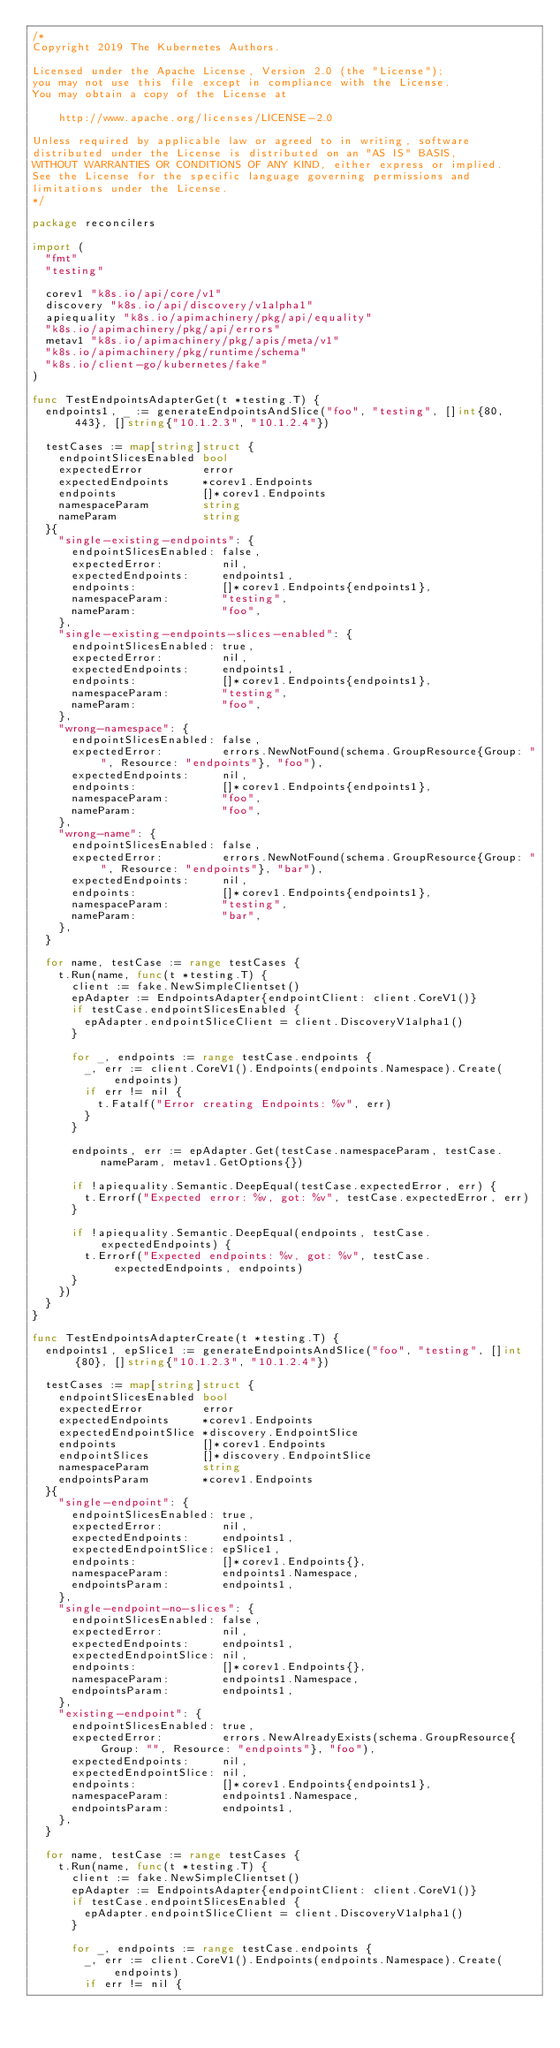<code> <loc_0><loc_0><loc_500><loc_500><_Go_>/*
Copyright 2019 The Kubernetes Authors.

Licensed under the Apache License, Version 2.0 (the "License");
you may not use this file except in compliance with the License.
You may obtain a copy of the License at

    http://www.apache.org/licenses/LICENSE-2.0

Unless required by applicable law or agreed to in writing, software
distributed under the License is distributed on an "AS IS" BASIS,
WITHOUT WARRANTIES OR CONDITIONS OF ANY KIND, either express or implied.
See the License for the specific language governing permissions and
limitations under the License.
*/

package reconcilers

import (
	"fmt"
	"testing"

	corev1 "k8s.io/api/core/v1"
	discovery "k8s.io/api/discovery/v1alpha1"
	apiequality "k8s.io/apimachinery/pkg/api/equality"
	"k8s.io/apimachinery/pkg/api/errors"
	metav1 "k8s.io/apimachinery/pkg/apis/meta/v1"
	"k8s.io/apimachinery/pkg/runtime/schema"
	"k8s.io/client-go/kubernetes/fake"
)

func TestEndpointsAdapterGet(t *testing.T) {
	endpoints1, _ := generateEndpointsAndSlice("foo", "testing", []int{80, 443}, []string{"10.1.2.3", "10.1.2.4"})

	testCases := map[string]struct {
		endpointSlicesEnabled bool
		expectedError         error
		expectedEndpoints     *corev1.Endpoints
		endpoints             []*corev1.Endpoints
		namespaceParam        string
		nameParam             string
	}{
		"single-existing-endpoints": {
			endpointSlicesEnabled: false,
			expectedError:         nil,
			expectedEndpoints:     endpoints1,
			endpoints:             []*corev1.Endpoints{endpoints1},
			namespaceParam:        "testing",
			nameParam:             "foo",
		},
		"single-existing-endpoints-slices-enabled": {
			endpointSlicesEnabled: true,
			expectedError:         nil,
			expectedEndpoints:     endpoints1,
			endpoints:             []*corev1.Endpoints{endpoints1},
			namespaceParam:        "testing",
			nameParam:             "foo",
		},
		"wrong-namespace": {
			endpointSlicesEnabled: false,
			expectedError:         errors.NewNotFound(schema.GroupResource{Group: "", Resource: "endpoints"}, "foo"),
			expectedEndpoints:     nil,
			endpoints:             []*corev1.Endpoints{endpoints1},
			namespaceParam:        "foo",
			nameParam:             "foo",
		},
		"wrong-name": {
			endpointSlicesEnabled: false,
			expectedError:         errors.NewNotFound(schema.GroupResource{Group: "", Resource: "endpoints"}, "bar"),
			expectedEndpoints:     nil,
			endpoints:             []*corev1.Endpoints{endpoints1},
			namespaceParam:        "testing",
			nameParam:             "bar",
		},
	}

	for name, testCase := range testCases {
		t.Run(name, func(t *testing.T) {
			client := fake.NewSimpleClientset()
			epAdapter := EndpointsAdapter{endpointClient: client.CoreV1()}
			if testCase.endpointSlicesEnabled {
				epAdapter.endpointSliceClient = client.DiscoveryV1alpha1()
			}

			for _, endpoints := range testCase.endpoints {
				_, err := client.CoreV1().Endpoints(endpoints.Namespace).Create(endpoints)
				if err != nil {
					t.Fatalf("Error creating Endpoints: %v", err)
				}
			}

			endpoints, err := epAdapter.Get(testCase.namespaceParam, testCase.nameParam, metav1.GetOptions{})

			if !apiequality.Semantic.DeepEqual(testCase.expectedError, err) {
				t.Errorf("Expected error: %v, got: %v", testCase.expectedError, err)
			}

			if !apiequality.Semantic.DeepEqual(endpoints, testCase.expectedEndpoints) {
				t.Errorf("Expected endpoints: %v, got: %v", testCase.expectedEndpoints, endpoints)
			}
		})
	}
}

func TestEndpointsAdapterCreate(t *testing.T) {
	endpoints1, epSlice1 := generateEndpointsAndSlice("foo", "testing", []int{80}, []string{"10.1.2.3", "10.1.2.4"})

	testCases := map[string]struct {
		endpointSlicesEnabled bool
		expectedError         error
		expectedEndpoints     *corev1.Endpoints
		expectedEndpointSlice *discovery.EndpointSlice
		endpoints             []*corev1.Endpoints
		endpointSlices        []*discovery.EndpointSlice
		namespaceParam        string
		endpointsParam        *corev1.Endpoints
	}{
		"single-endpoint": {
			endpointSlicesEnabled: true,
			expectedError:         nil,
			expectedEndpoints:     endpoints1,
			expectedEndpointSlice: epSlice1,
			endpoints:             []*corev1.Endpoints{},
			namespaceParam:        endpoints1.Namespace,
			endpointsParam:        endpoints1,
		},
		"single-endpoint-no-slices": {
			endpointSlicesEnabled: false,
			expectedError:         nil,
			expectedEndpoints:     endpoints1,
			expectedEndpointSlice: nil,
			endpoints:             []*corev1.Endpoints{},
			namespaceParam:        endpoints1.Namespace,
			endpointsParam:        endpoints1,
		},
		"existing-endpoint": {
			endpointSlicesEnabled: true,
			expectedError:         errors.NewAlreadyExists(schema.GroupResource{Group: "", Resource: "endpoints"}, "foo"),
			expectedEndpoints:     nil,
			expectedEndpointSlice: nil,
			endpoints:             []*corev1.Endpoints{endpoints1},
			namespaceParam:        endpoints1.Namespace,
			endpointsParam:        endpoints1,
		},
	}

	for name, testCase := range testCases {
		t.Run(name, func(t *testing.T) {
			client := fake.NewSimpleClientset()
			epAdapter := EndpointsAdapter{endpointClient: client.CoreV1()}
			if testCase.endpointSlicesEnabled {
				epAdapter.endpointSliceClient = client.DiscoveryV1alpha1()
			}

			for _, endpoints := range testCase.endpoints {
				_, err := client.CoreV1().Endpoints(endpoints.Namespace).Create(endpoints)
				if err != nil {</code> 